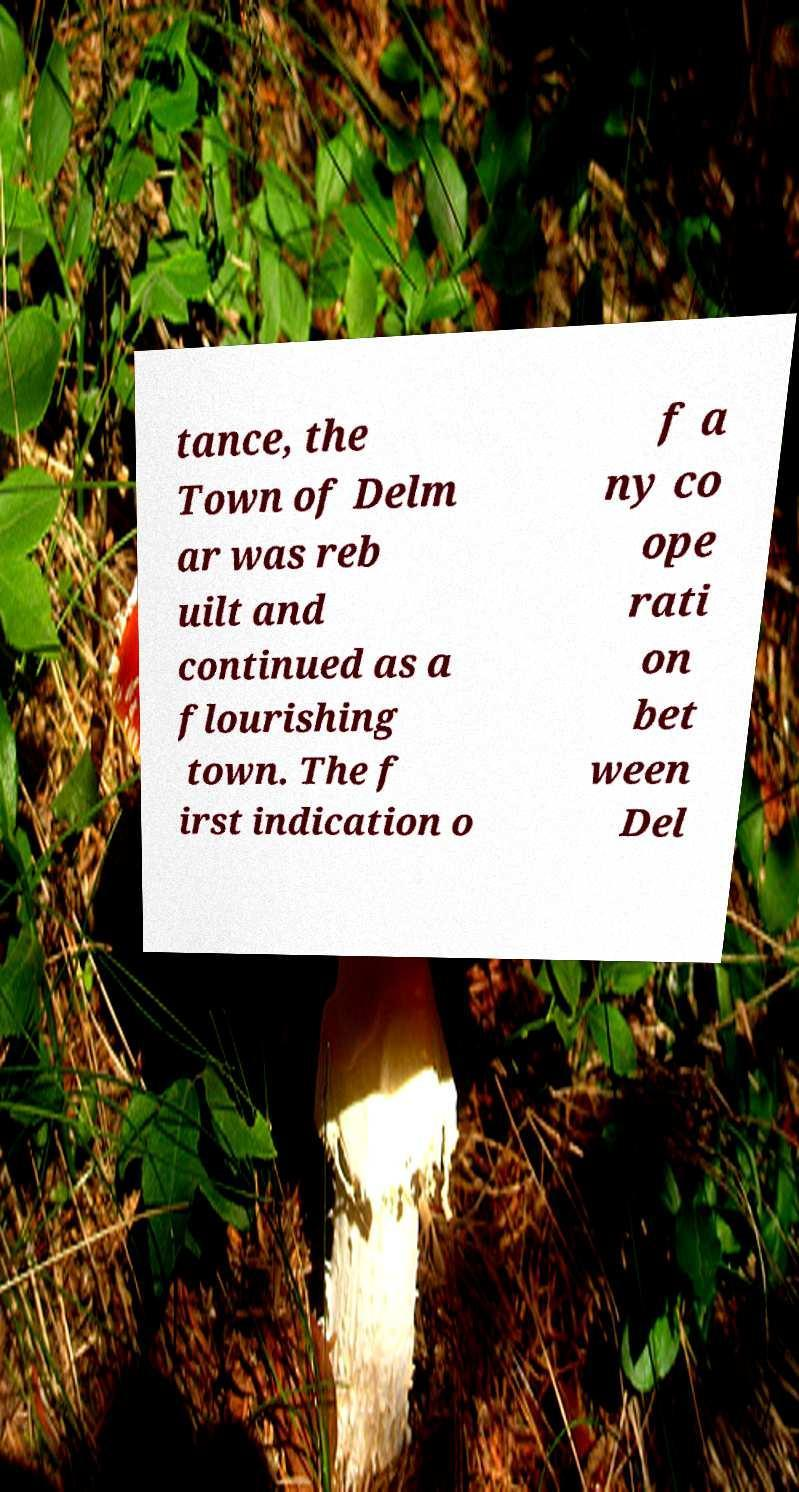What messages or text are displayed in this image? I need them in a readable, typed format. tance, the Town of Delm ar was reb uilt and continued as a flourishing town. The f irst indication o f a ny co ope rati on bet ween Del 